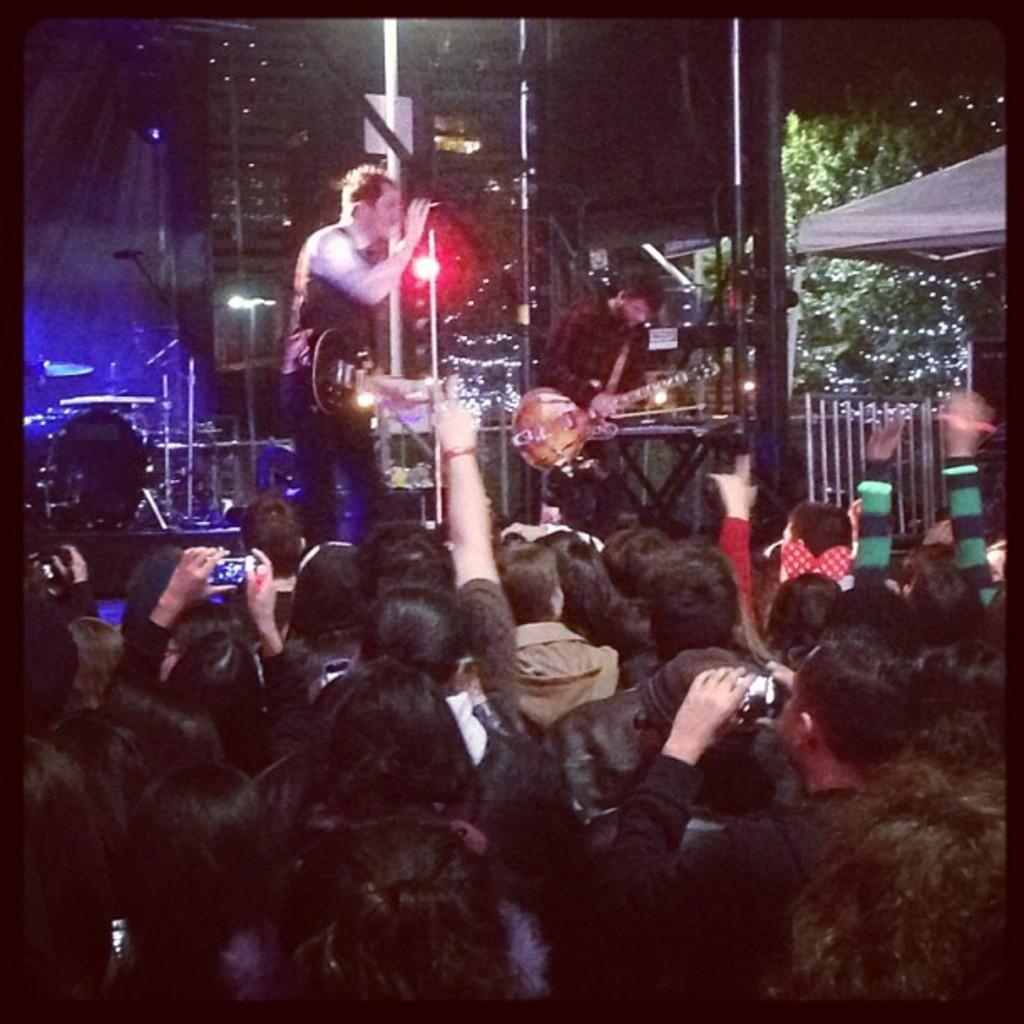How many men are in the image? There are two men in the image. What are the men holding in the image? The men are holding guitars. What activity are the men engaged in? The men are performing in a concert. Who else is present in the image besides the two men? There is a group of people in the image. How are the group of people reacting to the performance? The group of people are enjoying the performance. What committee is responsible for organizing the current event in the image? There is no mention of a committee or current event in the image; it simply shows two men performing with guitars and a group of people enjoying the performance. 